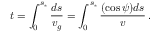<formula> <loc_0><loc_0><loc_500><loc_500>t = \int _ { 0 } ^ { s _ { * } } \frac { d s } { v _ { g } } = \int _ { 0 } ^ { s _ { * } } \frac { ( \cos \psi ) d s } { v } \, .</formula> 